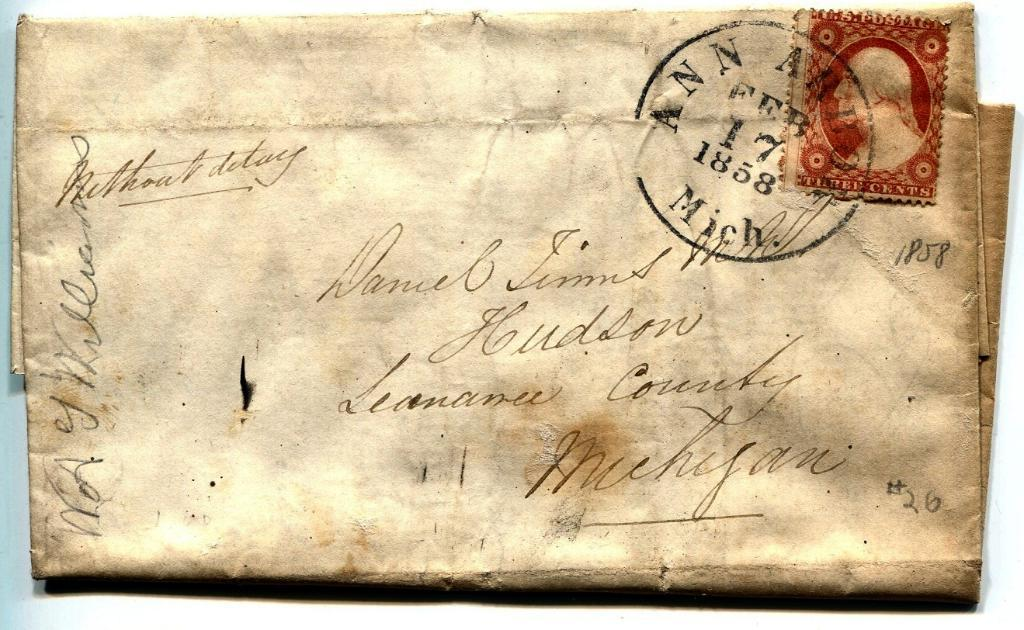<image>
Share a concise interpretation of the image provided. old letter from 1858 addressed to daniel simms 